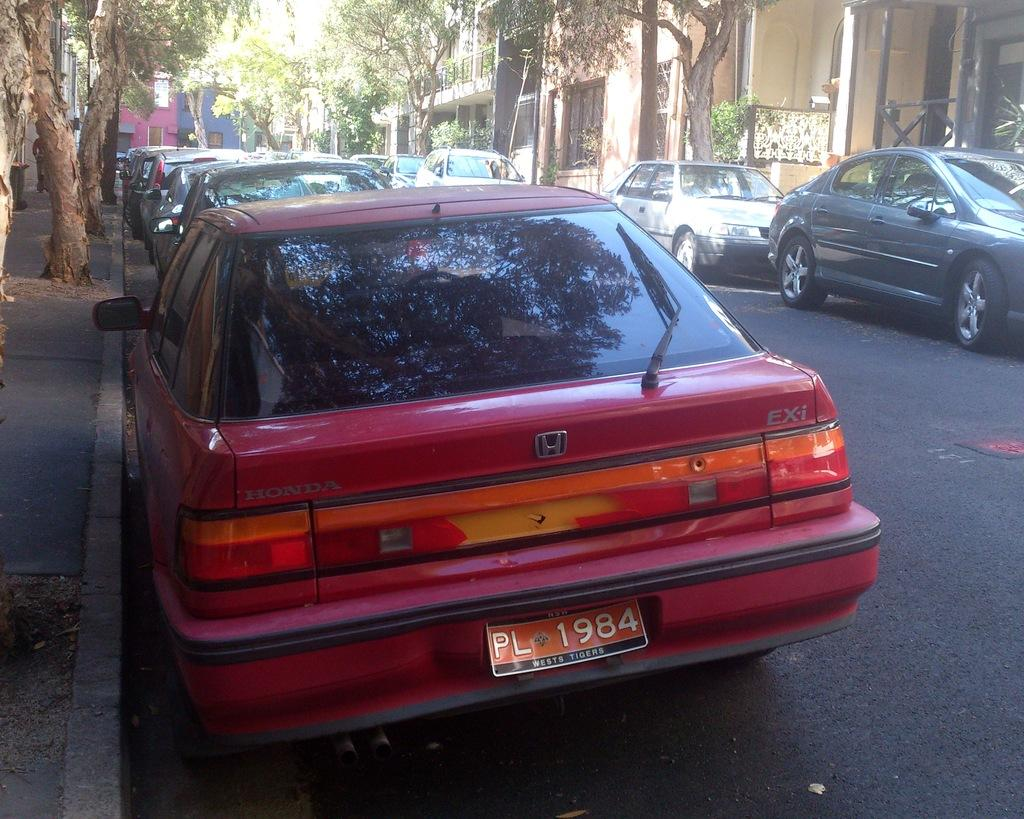What can be seen in the center of the image? There are cars on the road in the center of the image. What type of vegetation is visible in the image? There are trees visible in the image. What can be seen in the background of the image? There are buildings in the background of the image. What type of sock is hanging from the tree in the image? There is no sock hanging from a tree in the image; there are only trees and cars visible. 